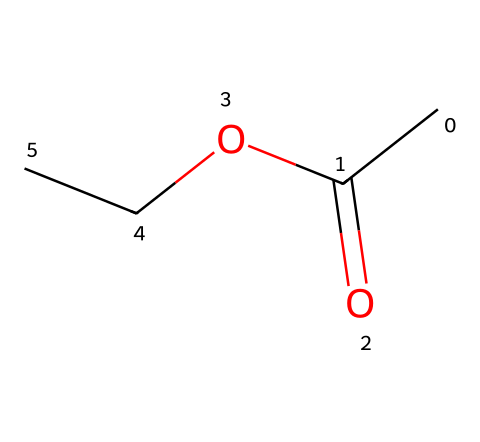What is the chemical name of this compound? The SMILES representation reveals the structure of the compound, which consists of an acetate functional group (from the CC(=O)O) and an ethyl group (OCC). This corresponds to the well-known solvent ethyl acetate.
Answer: ethyl acetate How many carbon atoms are present in the structure? Analyzing the SMILES representation, "CC(=O)OCC" contains four carbon atoms in total: two from the ethyl group on the right and two from the acetate group on the left.
Answer: four How many oxygen atoms are present in this molecule? In the SMILES representation, there are two oxygen atoms indicated: one in the ester functional group (from =O) and one in the ether part (from -O).
Answer: two Is this compound a polar or nonpolar solvent? With the presence of the electronegative oxygen atoms and hydroxyl groups, the molecule has polar characteristics. However, the overall structure's balance of nonpolar alkyl chains leads to it being categorized as a polar aprotic solvent.
Answer: polar What functional group characterizes ethyl acetate? The structure shows a carbonyl group (C=O) and an ether section (C-O-C), which together define the ester functional group that is specifically characteristic of ethyl acetate.
Answer: ester What type of reaction would produce ethyl acetate? Ethyl acetate is commonly produced via an esterification reaction, where an alcohol (ethanol) reacts with an acid (acetic acid) to form the ester, water, and heat as byproducts.
Answer: esterification What is the primary use of ethyl acetate in industries? Ethyl acetate is widely used as a solvent in various applications, particularly for cleaning products and in the paint and coatings industries, due to its ability to dissolve a wide range of substances.
Answer: solvent 